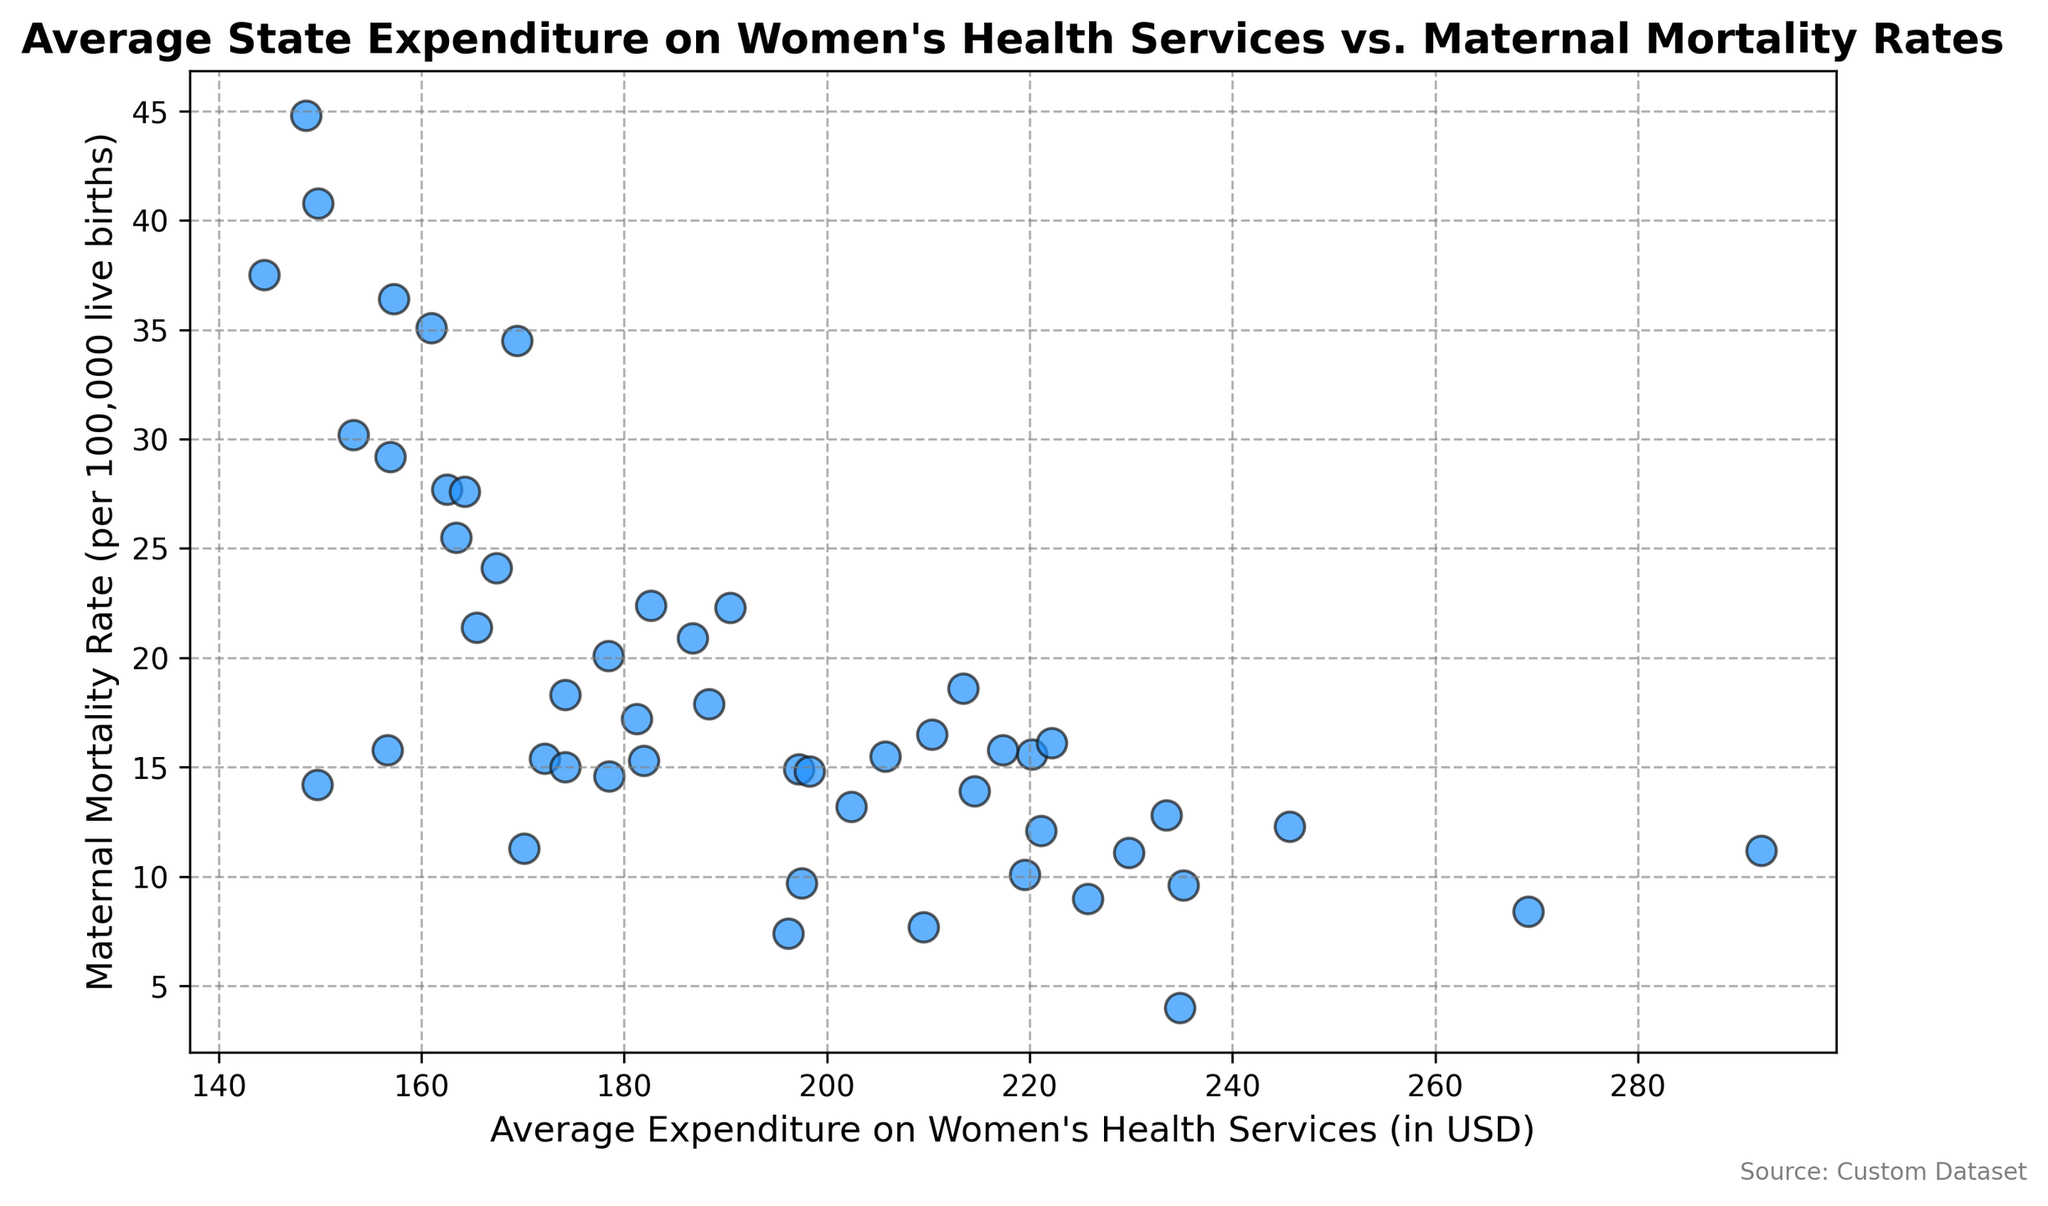what state has the highest maternal mortality rate? From the scatter plot, locate the highest point on the y-axis representing maternal mortality rate and identify the state associated with that point.
Answer: Louisiana What is the difference in average expenditure between the state with the highest maternal mortality rate and the state with the lowest maternal mortality rate? From the scatter plot, first identify the states with the highest and lowest maternal mortality rates (Louisiana and California). Then, find the corresponding average expenditures and compute the difference: 148.58 (Louisiana) - 234.81 (California).
Answer: -86.23 Does there appear to be a correlation between average state expenditure on women's health services and maternal mortality rates? Inspect the overall trend in the scatter plot. If dots show an inverse relationship (i.e., higher expenditure generally results in a lower maternal mortality rate), there might be a negative correlation.
Answer: Yes, a negative correlation is suggested Which state has the highest expenditure on women's health services? From the scatter plot, identify the right-most point on the x-axis representing the average expenditure and find the state associated with it.
Answer: Alaska Compare the maternal mortality rate between a state with average expenditure around 200 USD and another state with around 160 USD. Identify states with expenditures near 200 USD (e.g., Colorado) and 160 USD (e.g., Georgia), then compare their maternal mortality rates: 13.2 (Colorado) vs. 27.7 (Georgia).
Answer: Colorado: 13.2, Georgia: 27.7 Which state falls closest to a maternal mortality rate of 15 per 100,000 live births? Locate the point on the scatter plot nearest to 15 on the y-axis and determine the corresponding state.
Answer: Utah What is the average maternal mortality rate of states that spend more than 200 USD on women's health services? Identify points with expenditures > 200 USD, note their maternal mortality rates, and calculate the average. Rates: 13.2, 10.1, 14.9, 8.4, 16.5, 9.0, 11.3, 15.6, 4.0, 7.7, 8.4, 7.4. Average: (145.3/12).
Answer: 12.1 Is there an outlier in the data that stands out in terms of maternal mortality rate and how does it compare to others? Look for any point significantly higher or lower than others on the y-axis. Identify the state and compare with the second highest mortality rate. Louisiana at 44.8 stands out, comparing to the second highest, Mississippi at 40.8.
Answer: Louisiana: 44.8, Mississippi: 40.8 